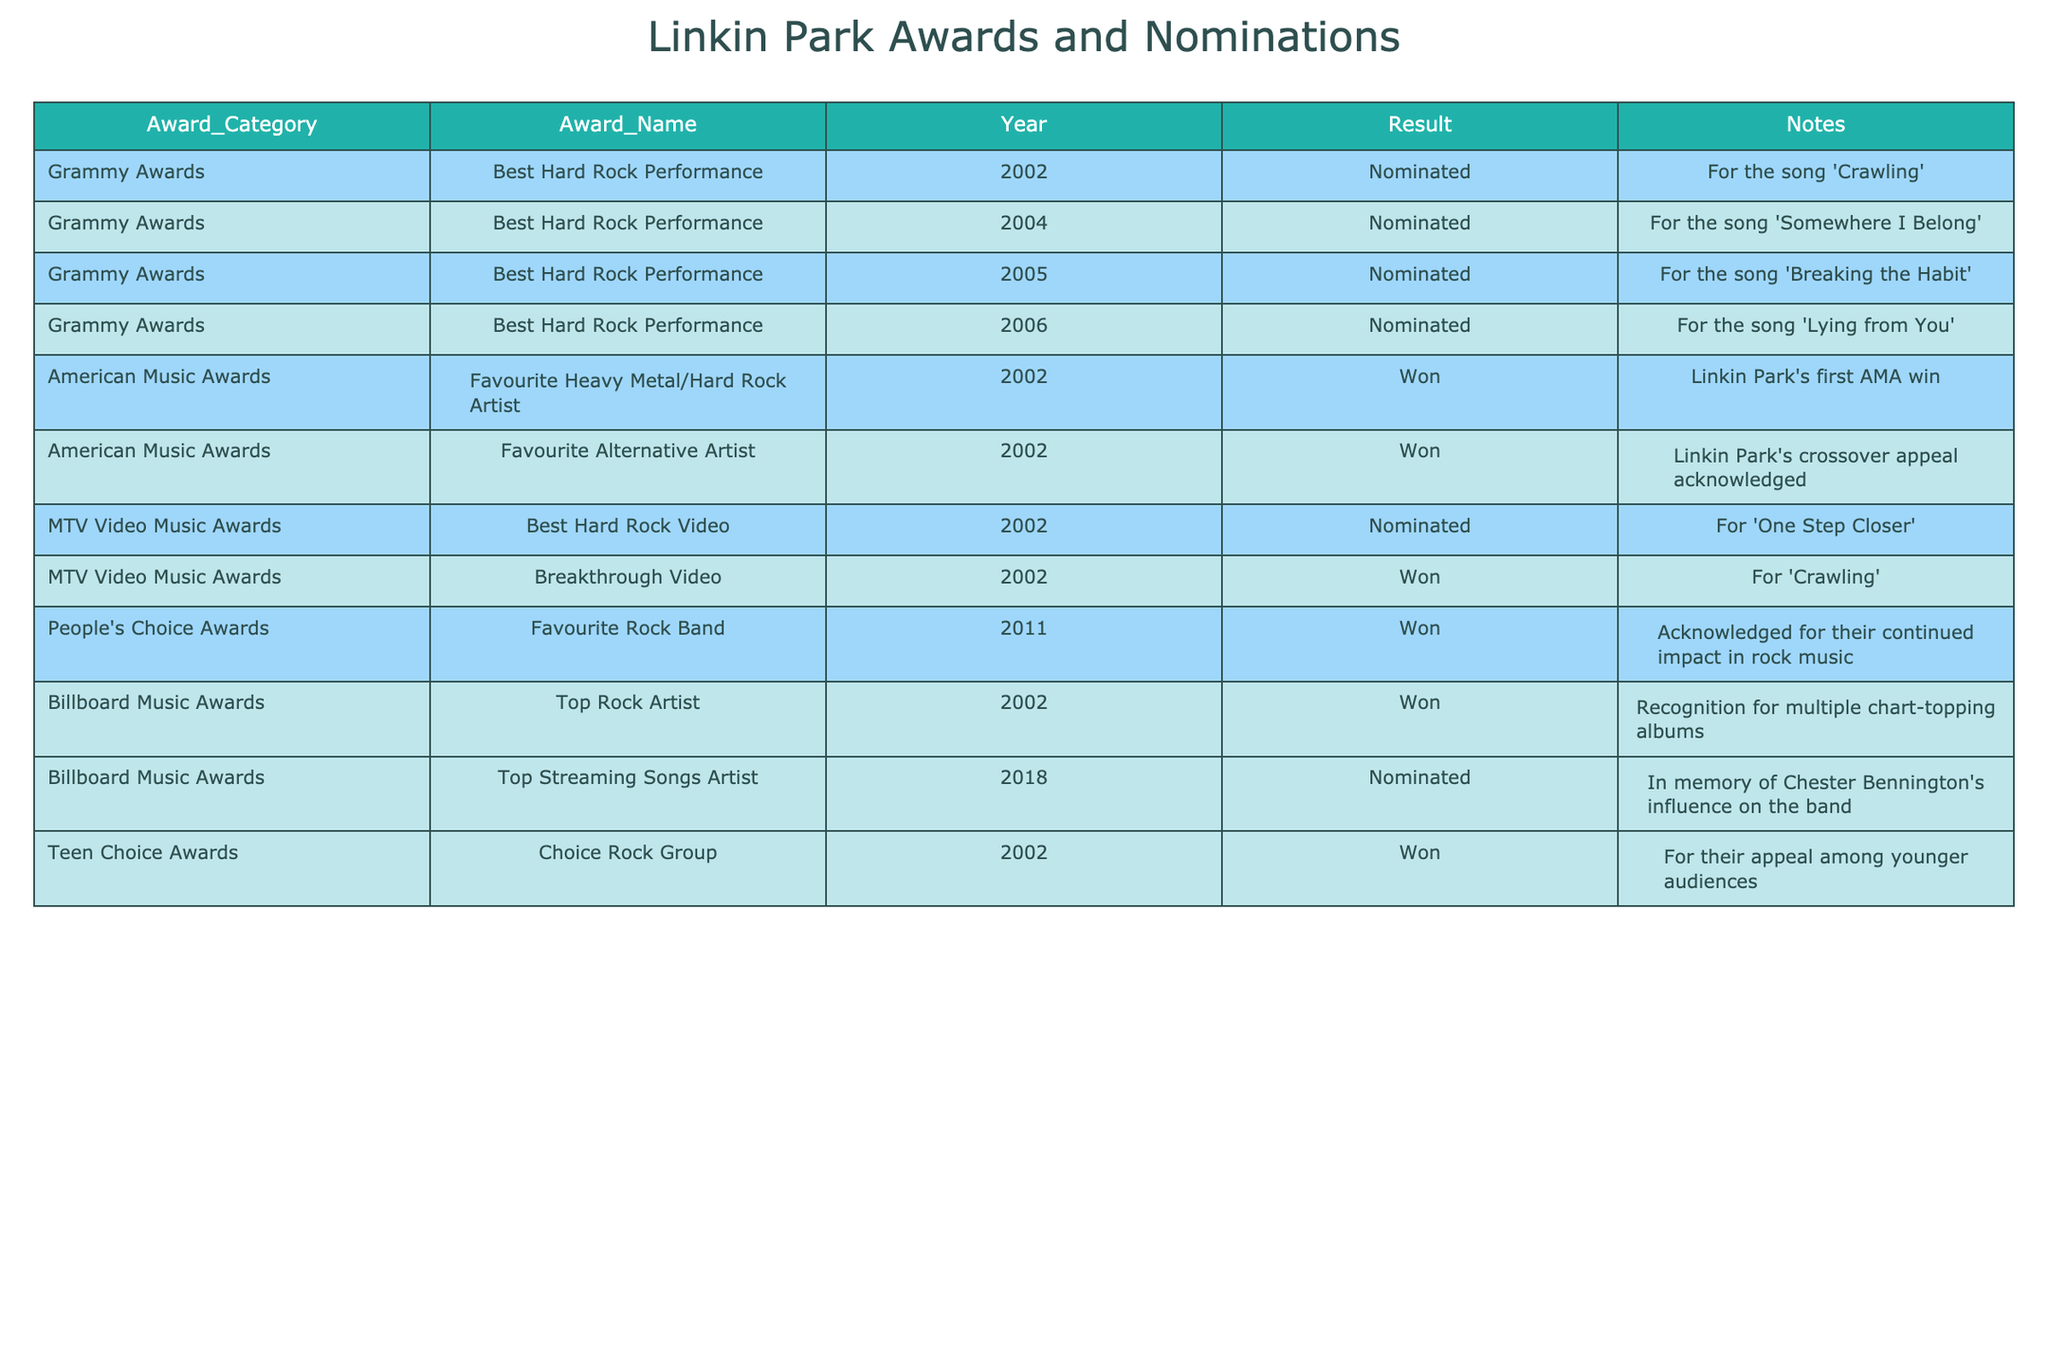What year did Linkin Park win their first Grammy Award? The table does not list any 'won' results for the Grammy Awards, only nominations are present. Therefore, Linkin Park has not won a Grammy Award.
Answer: No How many times was Linkin Park nominated for the Best Hard Rock Performance at the Grammy Awards? By examining the 'Award_Category' for Grammy Awards under 'Best Hard Rock Performance', I find four nominations in the years 2002, 2004, 2005, and 2006.
Answer: 4 What is the total number of awards won by Linkin Park in 2002? In 2002, Linkin Park won three awards: 'Favourite Heavy Metal/Hard Rock Artist' at the American Music Awards, 'Breakthrough Video' at the MTV Video Music Awards, and 'Top Rock Artist' at the Billboard Music Awards.
Answer: 3 Did Linkin Park receive an American Music Award in 2011? The table lists an award received in 2011, specifically for 'Favourite Rock Band', indicating they did indeed receive an American Music Award in that year.
Answer: Yes What is the difference between the number of nominations and wins for Linkin Park at the Grammy Awards? Linkin Park has four nominations but no wins at the Grammy Awards. The difference is 4 (nominations) - 0 (wins) = 4.
Answer: 4 How many awards did Linkin Park win between 2002 and 2011? In the given years, the wins in the table include 2002 (3 wins: AMA, MTV VMA, Billboard), and 2011 (1 win: People's Choice Award), resulting in a total of 3 + 1 = 4 wins.
Answer: 4 Which award did Linkin Park win for the video 'Crawling'? According to the table, Linkin Park won the 'Breakthrough Video' award at the MTV Video Music Awards for the song 'Crawling' in 2002.
Answer: Breakthrough Video Was there any nomination for Linkin Park at the Billboard Music Awards in 2018? The table indicates that Linkin Park was indeed nominated for 'Top Streaming Songs Artist' in 2018, hence they had a nomination that year.
Answer: Yes What percentage of Linkin Park's nominations resulted in wins at the American Music Awards? With 2 wins and 2 nominations at the American Music Awards in 2002, the percentage is calculated as (2 wins / 2 nominations) * 100 = 100%.
Answer: 100% 